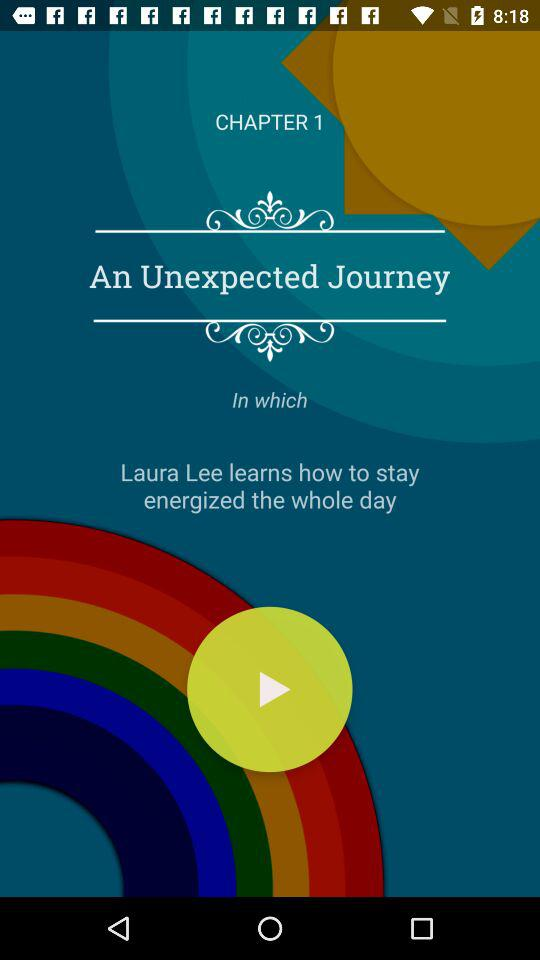What is the name of the user? The name of the user is Laura Lee. 